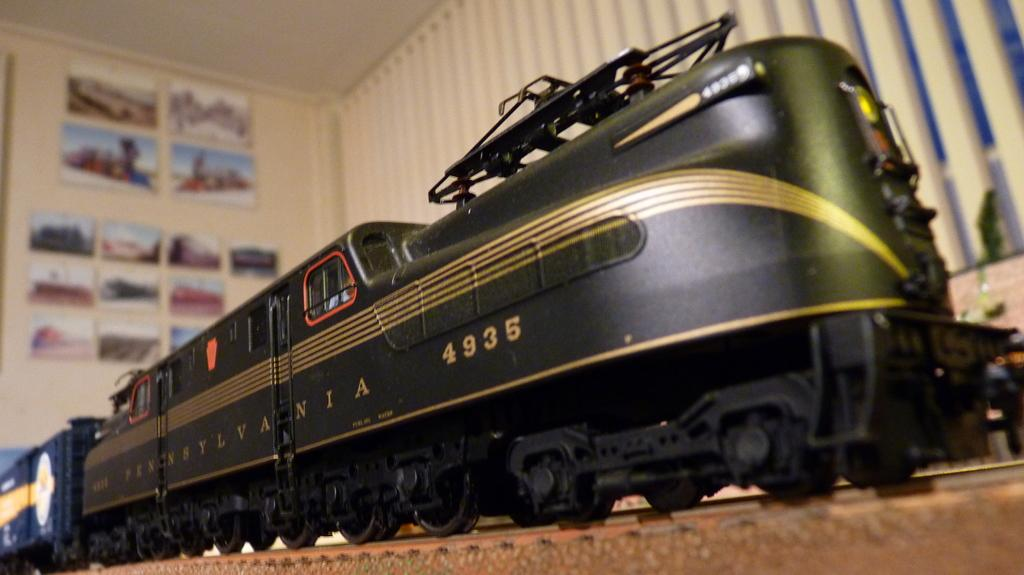What is the main subject in the foreground of the image? There is a toy train in the foreground of the image. What can be seen in the background of the image? There are frames on the wall in the background of the image. What type of wood is used to build the drawer in the image? There is no drawer present in the image. What does the hope symbolize in the image? The image does not depict any symbol of hope. 